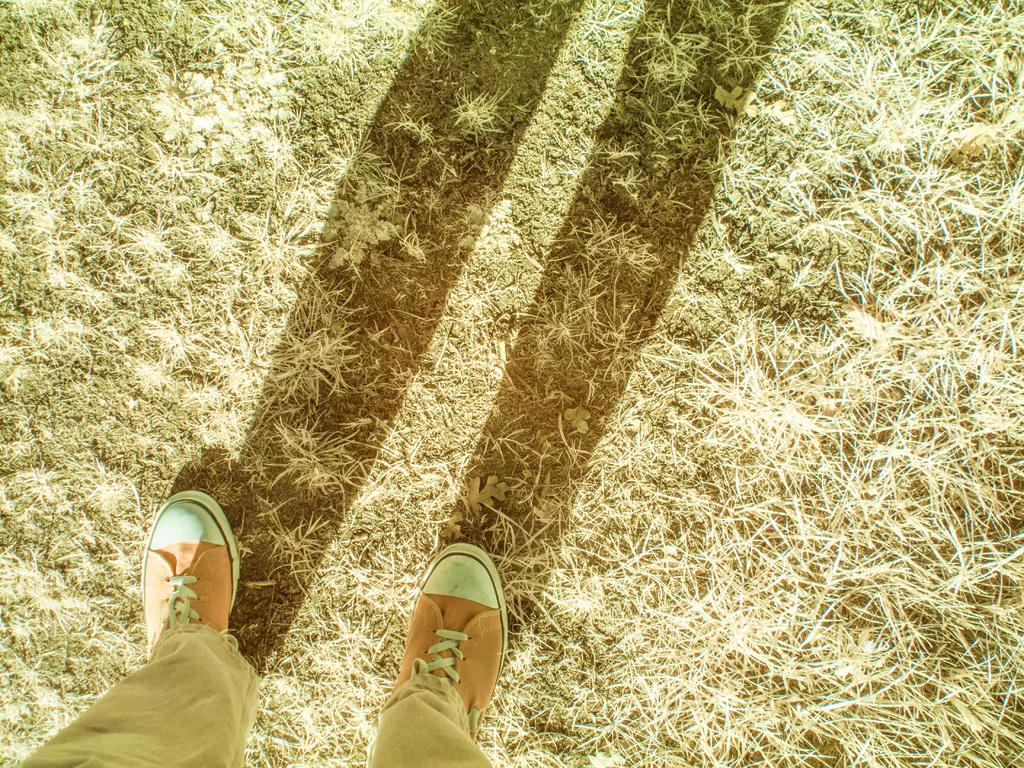What is visible in the foreground of the image? There are two legs of a person in the foreground of the image. What can be seen on the grassland in the image? There is a shadow on the grassland in the image. What type of wool is being used to make the beds in the image? There are no beds present in the image, so it is not possible to determine what type of wool might be used. 